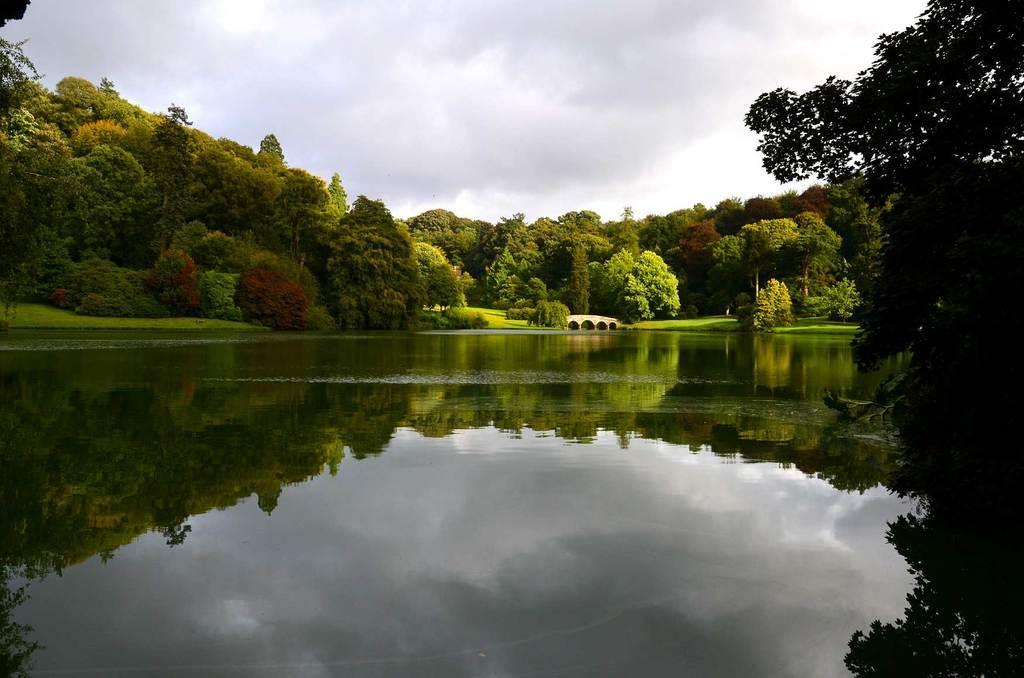Please provide a concise description of this image. In this picture I can see trees, water and a bridge and I can see cloudy sky. 